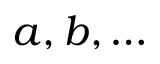Convert formula to latex. <formula><loc_0><loc_0><loc_500><loc_500>a , b , \dots</formula> 